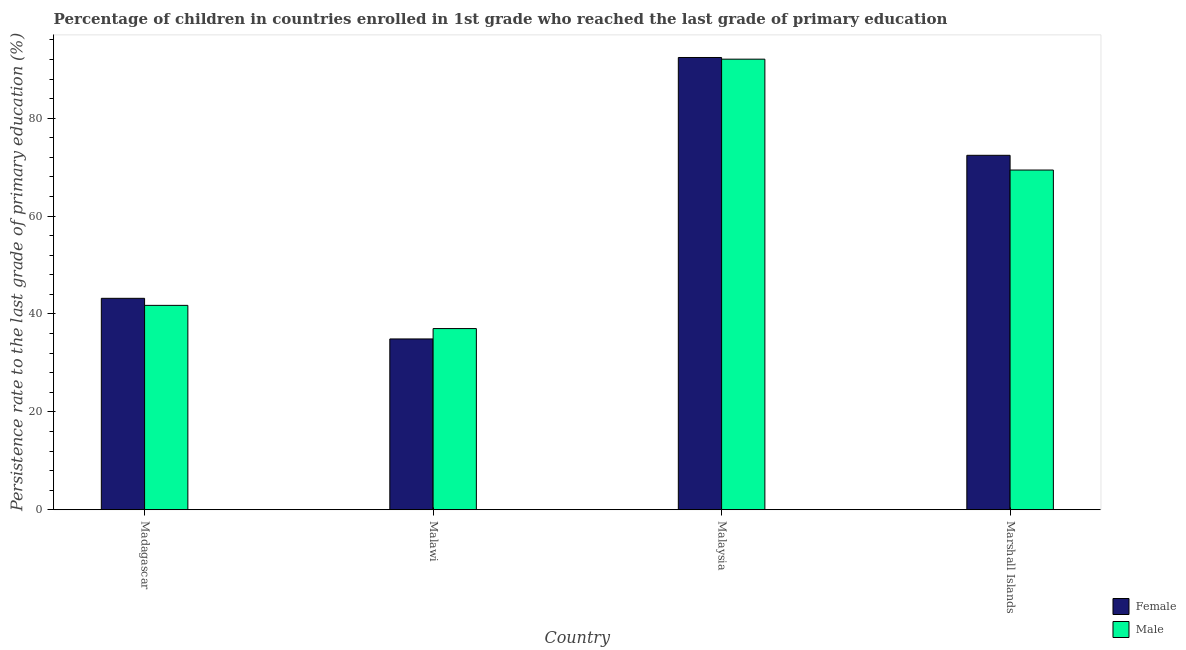How many different coloured bars are there?
Make the answer very short. 2. Are the number of bars on each tick of the X-axis equal?
Offer a very short reply. Yes. What is the label of the 4th group of bars from the left?
Provide a short and direct response. Marshall Islands. In how many cases, is the number of bars for a given country not equal to the number of legend labels?
Your answer should be very brief. 0. What is the persistence rate of male students in Malaysia?
Provide a short and direct response. 92.06. Across all countries, what is the maximum persistence rate of male students?
Provide a short and direct response. 92.06. Across all countries, what is the minimum persistence rate of female students?
Provide a succinct answer. 34.9. In which country was the persistence rate of male students maximum?
Your answer should be compact. Malaysia. In which country was the persistence rate of male students minimum?
Provide a succinct answer. Malawi. What is the total persistence rate of female students in the graph?
Your answer should be very brief. 242.92. What is the difference between the persistence rate of female students in Malawi and that in Malaysia?
Make the answer very short. -57.5. What is the difference between the persistence rate of male students in Madagascar and the persistence rate of female students in Malawi?
Offer a terse response. 6.86. What is the average persistence rate of female students per country?
Your answer should be very brief. 60.73. What is the difference between the persistence rate of male students and persistence rate of female students in Marshall Islands?
Your response must be concise. -3.01. In how many countries, is the persistence rate of male students greater than 88 %?
Your answer should be compact. 1. What is the ratio of the persistence rate of male students in Malawi to that in Malaysia?
Your answer should be compact. 0.4. Is the persistence rate of male students in Madagascar less than that in Marshall Islands?
Make the answer very short. Yes. What is the difference between the highest and the second highest persistence rate of female students?
Make the answer very short. 19.98. What is the difference between the highest and the lowest persistence rate of female students?
Your answer should be compact. 57.5. In how many countries, is the persistence rate of female students greater than the average persistence rate of female students taken over all countries?
Offer a terse response. 2. What does the 2nd bar from the left in Marshall Islands represents?
Give a very brief answer. Male. What does the 2nd bar from the right in Madagascar represents?
Your answer should be compact. Female. Are all the bars in the graph horizontal?
Offer a terse response. No. How many countries are there in the graph?
Offer a terse response. 4. Are the values on the major ticks of Y-axis written in scientific E-notation?
Provide a short and direct response. No. Does the graph contain any zero values?
Make the answer very short. No. Does the graph contain grids?
Offer a very short reply. No. Where does the legend appear in the graph?
Provide a succinct answer. Bottom right. How are the legend labels stacked?
Your answer should be compact. Vertical. What is the title of the graph?
Offer a terse response. Percentage of children in countries enrolled in 1st grade who reached the last grade of primary education. What is the label or title of the X-axis?
Your response must be concise. Country. What is the label or title of the Y-axis?
Offer a terse response. Persistence rate to the last grade of primary education (%). What is the Persistence rate to the last grade of primary education (%) in Female in Madagascar?
Make the answer very short. 43.2. What is the Persistence rate to the last grade of primary education (%) of Male in Madagascar?
Provide a short and direct response. 41.76. What is the Persistence rate to the last grade of primary education (%) of Female in Malawi?
Give a very brief answer. 34.9. What is the Persistence rate to the last grade of primary education (%) of Male in Malawi?
Offer a terse response. 37.02. What is the Persistence rate to the last grade of primary education (%) in Female in Malaysia?
Your answer should be very brief. 92.4. What is the Persistence rate to the last grade of primary education (%) of Male in Malaysia?
Make the answer very short. 92.06. What is the Persistence rate to the last grade of primary education (%) of Female in Marshall Islands?
Your answer should be compact. 72.42. What is the Persistence rate to the last grade of primary education (%) of Male in Marshall Islands?
Give a very brief answer. 69.41. Across all countries, what is the maximum Persistence rate to the last grade of primary education (%) of Female?
Your answer should be compact. 92.4. Across all countries, what is the maximum Persistence rate to the last grade of primary education (%) of Male?
Offer a very short reply. 92.06. Across all countries, what is the minimum Persistence rate to the last grade of primary education (%) in Female?
Ensure brevity in your answer.  34.9. Across all countries, what is the minimum Persistence rate to the last grade of primary education (%) of Male?
Give a very brief answer. 37.02. What is the total Persistence rate to the last grade of primary education (%) of Female in the graph?
Offer a terse response. 242.92. What is the total Persistence rate to the last grade of primary education (%) of Male in the graph?
Your answer should be compact. 240.25. What is the difference between the Persistence rate to the last grade of primary education (%) of Female in Madagascar and that in Malawi?
Your answer should be very brief. 8.3. What is the difference between the Persistence rate to the last grade of primary education (%) of Male in Madagascar and that in Malawi?
Your response must be concise. 4.74. What is the difference between the Persistence rate to the last grade of primary education (%) in Female in Madagascar and that in Malaysia?
Keep it short and to the point. -49.2. What is the difference between the Persistence rate to the last grade of primary education (%) of Male in Madagascar and that in Malaysia?
Give a very brief answer. -50.3. What is the difference between the Persistence rate to the last grade of primary education (%) of Female in Madagascar and that in Marshall Islands?
Keep it short and to the point. -29.22. What is the difference between the Persistence rate to the last grade of primary education (%) of Male in Madagascar and that in Marshall Islands?
Provide a short and direct response. -27.65. What is the difference between the Persistence rate to the last grade of primary education (%) of Female in Malawi and that in Malaysia?
Provide a succinct answer. -57.5. What is the difference between the Persistence rate to the last grade of primary education (%) of Male in Malawi and that in Malaysia?
Your response must be concise. -55.04. What is the difference between the Persistence rate to the last grade of primary education (%) of Female in Malawi and that in Marshall Islands?
Your answer should be very brief. -37.52. What is the difference between the Persistence rate to the last grade of primary education (%) of Male in Malawi and that in Marshall Islands?
Keep it short and to the point. -32.39. What is the difference between the Persistence rate to the last grade of primary education (%) in Female in Malaysia and that in Marshall Islands?
Your response must be concise. 19.98. What is the difference between the Persistence rate to the last grade of primary education (%) of Male in Malaysia and that in Marshall Islands?
Make the answer very short. 22.65. What is the difference between the Persistence rate to the last grade of primary education (%) in Female in Madagascar and the Persistence rate to the last grade of primary education (%) in Male in Malawi?
Keep it short and to the point. 6.18. What is the difference between the Persistence rate to the last grade of primary education (%) in Female in Madagascar and the Persistence rate to the last grade of primary education (%) in Male in Malaysia?
Your answer should be very brief. -48.86. What is the difference between the Persistence rate to the last grade of primary education (%) of Female in Madagascar and the Persistence rate to the last grade of primary education (%) of Male in Marshall Islands?
Your response must be concise. -26.21. What is the difference between the Persistence rate to the last grade of primary education (%) of Female in Malawi and the Persistence rate to the last grade of primary education (%) of Male in Malaysia?
Keep it short and to the point. -57.16. What is the difference between the Persistence rate to the last grade of primary education (%) of Female in Malawi and the Persistence rate to the last grade of primary education (%) of Male in Marshall Islands?
Make the answer very short. -34.51. What is the difference between the Persistence rate to the last grade of primary education (%) of Female in Malaysia and the Persistence rate to the last grade of primary education (%) of Male in Marshall Islands?
Your answer should be compact. 22.99. What is the average Persistence rate to the last grade of primary education (%) of Female per country?
Your response must be concise. 60.73. What is the average Persistence rate to the last grade of primary education (%) in Male per country?
Keep it short and to the point. 60.06. What is the difference between the Persistence rate to the last grade of primary education (%) of Female and Persistence rate to the last grade of primary education (%) of Male in Madagascar?
Offer a terse response. 1.44. What is the difference between the Persistence rate to the last grade of primary education (%) of Female and Persistence rate to the last grade of primary education (%) of Male in Malawi?
Give a very brief answer. -2.12. What is the difference between the Persistence rate to the last grade of primary education (%) in Female and Persistence rate to the last grade of primary education (%) in Male in Malaysia?
Make the answer very short. 0.34. What is the difference between the Persistence rate to the last grade of primary education (%) in Female and Persistence rate to the last grade of primary education (%) in Male in Marshall Islands?
Make the answer very short. 3.01. What is the ratio of the Persistence rate to the last grade of primary education (%) of Female in Madagascar to that in Malawi?
Provide a short and direct response. 1.24. What is the ratio of the Persistence rate to the last grade of primary education (%) of Male in Madagascar to that in Malawi?
Make the answer very short. 1.13. What is the ratio of the Persistence rate to the last grade of primary education (%) of Female in Madagascar to that in Malaysia?
Offer a very short reply. 0.47. What is the ratio of the Persistence rate to the last grade of primary education (%) of Male in Madagascar to that in Malaysia?
Provide a short and direct response. 0.45. What is the ratio of the Persistence rate to the last grade of primary education (%) of Female in Madagascar to that in Marshall Islands?
Provide a short and direct response. 0.6. What is the ratio of the Persistence rate to the last grade of primary education (%) of Male in Madagascar to that in Marshall Islands?
Give a very brief answer. 0.6. What is the ratio of the Persistence rate to the last grade of primary education (%) in Female in Malawi to that in Malaysia?
Give a very brief answer. 0.38. What is the ratio of the Persistence rate to the last grade of primary education (%) in Male in Malawi to that in Malaysia?
Your answer should be very brief. 0.4. What is the ratio of the Persistence rate to the last grade of primary education (%) in Female in Malawi to that in Marshall Islands?
Offer a very short reply. 0.48. What is the ratio of the Persistence rate to the last grade of primary education (%) in Male in Malawi to that in Marshall Islands?
Your answer should be compact. 0.53. What is the ratio of the Persistence rate to the last grade of primary education (%) of Female in Malaysia to that in Marshall Islands?
Your answer should be compact. 1.28. What is the ratio of the Persistence rate to the last grade of primary education (%) in Male in Malaysia to that in Marshall Islands?
Your answer should be very brief. 1.33. What is the difference between the highest and the second highest Persistence rate to the last grade of primary education (%) in Female?
Provide a short and direct response. 19.98. What is the difference between the highest and the second highest Persistence rate to the last grade of primary education (%) of Male?
Your answer should be very brief. 22.65. What is the difference between the highest and the lowest Persistence rate to the last grade of primary education (%) in Female?
Make the answer very short. 57.5. What is the difference between the highest and the lowest Persistence rate to the last grade of primary education (%) in Male?
Make the answer very short. 55.04. 